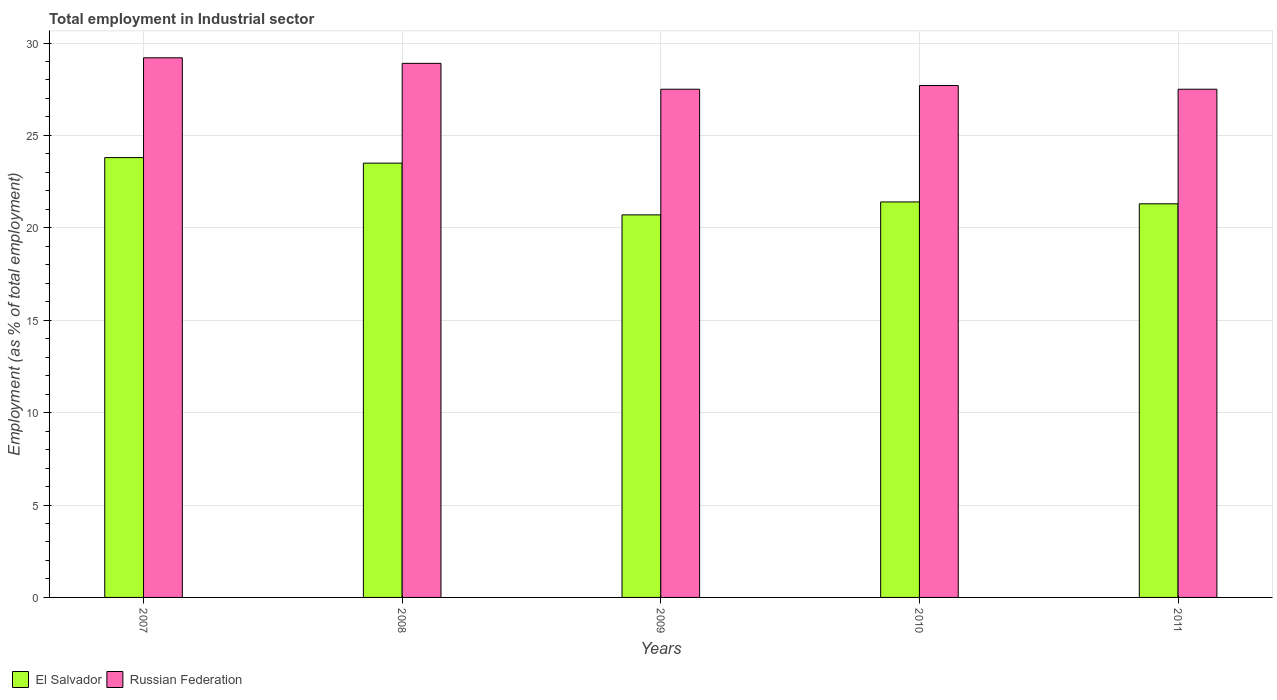How many different coloured bars are there?
Provide a short and direct response. 2. Are the number of bars per tick equal to the number of legend labels?
Offer a terse response. Yes. Are the number of bars on each tick of the X-axis equal?
Make the answer very short. Yes. How many bars are there on the 4th tick from the right?
Ensure brevity in your answer.  2. What is the label of the 2nd group of bars from the left?
Make the answer very short. 2008. In how many cases, is the number of bars for a given year not equal to the number of legend labels?
Offer a terse response. 0. What is the employment in industrial sector in Russian Federation in 2008?
Your response must be concise. 28.9. Across all years, what is the maximum employment in industrial sector in El Salvador?
Keep it short and to the point. 23.8. Across all years, what is the minimum employment in industrial sector in Russian Federation?
Make the answer very short. 27.5. In which year was the employment in industrial sector in El Salvador maximum?
Keep it short and to the point. 2007. What is the total employment in industrial sector in Russian Federation in the graph?
Keep it short and to the point. 140.8. What is the difference between the employment in industrial sector in Russian Federation in 2007 and that in 2008?
Offer a terse response. 0.3. What is the difference between the employment in industrial sector in El Salvador in 2011 and the employment in industrial sector in Russian Federation in 2010?
Give a very brief answer. -6.4. What is the average employment in industrial sector in El Salvador per year?
Provide a succinct answer. 22.14. In the year 2011, what is the difference between the employment in industrial sector in Russian Federation and employment in industrial sector in El Salvador?
Ensure brevity in your answer.  6.2. What is the ratio of the employment in industrial sector in Russian Federation in 2009 to that in 2010?
Your answer should be compact. 0.99. What is the difference between the highest and the second highest employment in industrial sector in El Salvador?
Offer a terse response. 0.3. What is the difference between the highest and the lowest employment in industrial sector in Russian Federation?
Provide a short and direct response. 1.7. In how many years, is the employment in industrial sector in El Salvador greater than the average employment in industrial sector in El Salvador taken over all years?
Offer a terse response. 2. Is the sum of the employment in industrial sector in Russian Federation in 2008 and 2010 greater than the maximum employment in industrial sector in El Salvador across all years?
Your answer should be very brief. Yes. What does the 2nd bar from the left in 2007 represents?
Your answer should be compact. Russian Federation. What does the 1st bar from the right in 2011 represents?
Provide a short and direct response. Russian Federation. How many years are there in the graph?
Provide a short and direct response. 5. What is the difference between two consecutive major ticks on the Y-axis?
Offer a terse response. 5. Does the graph contain grids?
Provide a short and direct response. Yes. How many legend labels are there?
Give a very brief answer. 2. How are the legend labels stacked?
Offer a very short reply. Horizontal. What is the title of the graph?
Make the answer very short. Total employment in Industrial sector. What is the label or title of the X-axis?
Your answer should be compact. Years. What is the label or title of the Y-axis?
Your answer should be compact. Employment (as % of total employment). What is the Employment (as % of total employment) of El Salvador in 2007?
Provide a short and direct response. 23.8. What is the Employment (as % of total employment) in Russian Federation in 2007?
Ensure brevity in your answer.  29.2. What is the Employment (as % of total employment) of Russian Federation in 2008?
Your answer should be very brief. 28.9. What is the Employment (as % of total employment) of El Salvador in 2009?
Keep it short and to the point. 20.7. What is the Employment (as % of total employment) of El Salvador in 2010?
Offer a very short reply. 21.4. What is the Employment (as % of total employment) in Russian Federation in 2010?
Your response must be concise. 27.7. What is the Employment (as % of total employment) of El Salvador in 2011?
Keep it short and to the point. 21.3. Across all years, what is the maximum Employment (as % of total employment) of El Salvador?
Provide a succinct answer. 23.8. Across all years, what is the maximum Employment (as % of total employment) of Russian Federation?
Keep it short and to the point. 29.2. Across all years, what is the minimum Employment (as % of total employment) of El Salvador?
Keep it short and to the point. 20.7. Across all years, what is the minimum Employment (as % of total employment) in Russian Federation?
Your response must be concise. 27.5. What is the total Employment (as % of total employment) in El Salvador in the graph?
Give a very brief answer. 110.7. What is the total Employment (as % of total employment) in Russian Federation in the graph?
Your answer should be very brief. 140.8. What is the difference between the Employment (as % of total employment) of El Salvador in 2007 and that in 2009?
Make the answer very short. 3.1. What is the difference between the Employment (as % of total employment) of Russian Federation in 2007 and that in 2009?
Your answer should be very brief. 1.7. What is the difference between the Employment (as % of total employment) of El Salvador in 2008 and that in 2009?
Your answer should be very brief. 2.8. What is the difference between the Employment (as % of total employment) of Russian Federation in 2008 and that in 2010?
Offer a terse response. 1.2. What is the difference between the Employment (as % of total employment) in Russian Federation in 2009 and that in 2010?
Provide a succinct answer. -0.2. What is the difference between the Employment (as % of total employment) in El Salvador in 2009 and that in 2011?
Your response must be concise. -0.6. What is the difference between the Employment (as % of total employment) in El Salvador in 2010 and that in 2011?
Give a very brief answer. 0.1. What is the difference between the Employment (as % of total employment) of El Salvador in 2007 and the Employment (as % of total employment) of Russian Federation in 2009?
Provide a succinct answer. -3.7. What is the difference between the Employment (as % of total employment) in El Salvador in 2008 and the Employment (as % of total employment) in Russian Federation in 2009?
Provide a succinct answer. -4. What is the average Employment (as % of total employment) in El Salvador per year?
Offer a very short reply. 22.14. What is the average Employment (as % of total employment) in Russian Federation per year?
Your response must be concise. 28.16. In the year 2008, what is the difference between the Employment (as % of total employment) of El Salvador and Employment (as % of total employment) of Russian Federation?
Give a very brief answer. -5.4. In the year 2009, what is the difference between the Employment (as % of total employment) of El Salvador and Employment (as % of total employment) of Russian Federation?
Make the answer very short. -6.8. In the year 2011, what is the difference between the Employment (as % of total employment) of El Salvador and Employment (as % of total employment) of Russian Federation?
Give a very brief answer. -6.2. What is the ratio of the Employment (as % of total employment) in El Salvador in 2007 to that in 2008?
Make the answer very short. 1.01. What is the ratio of the Employment (as % of total employment) of Russian Federation in 2007 to that in 2008?
Your answer should be very brief. 1.01. What is the ratio of the Employment (as % of total employment) of El Salvador in 2007 to that in 2009?
Provide a short and direct response. 1.15. What is the ratio of the Employment (as % of total employment) in Russian Federation in 2007 to that in 2009?
Your response must be concise. 1.06. What is the ratio of the Employment (as % of total employment) of El Salvador in 2007 to that in 2010?
Offer a terse response. 1.11. What is the ratio of the Employment (as % of total employment) in Russian Federation in 2007 to that in 2010?
Ensure brevity in your answer.  1.05. What is the ratio of the Employment (as % of total employment) in El Salvador in 2007 to that in 2011?
Make the answer very short. 1.12. What is the ratio of the Employment (as % of total employment) in Russian Federation in 2007 to that in 2011?
Your answer should be compact. 1.06. What is the ratio of the Employment (as % of total employment) in El Salvador in 2008 to that in 2009?
Offer a very short reply. 1.14. What is the ratio of the Employment (as % of total employment) in Russian Federation in 2008 to that in 2009?
Provide a succinct answer. 1.05. What is the ratio of the Employment (as % of total employment) in El Salvador in 2008 to that in 2010?
Your answer should be very brief. 1.1. What is the ratio of the Employment (as % of total employment) in Russian Federation in 2008 to that in 2010?
Make the answer very short. 1.04. What is the ratio of the Employment (as % of total employment) of El Salvador in 2008 to that in 2011?
Provide a short and direct response. 1.1. What is the ratio of the Employment (as % of total employment) of Russian Federation in 2008 to that in 2011?
Provide a short and direct response. 1.05. What is the ratio of the Employment (as % of total employment) in El Salvador in 2009 to that in 2010?
Provide a succinct answer. 0.97. What is the ratio of the Employment (as % of total employment) in El Salvador in 2009 to that in 2011?
Your response must be concise. 0.97. What is the ratio of the Employment (as % of total employment) of Russian Federation in 2009 to that in 2011?
Make the answer very short. 1. What is the ratio of the Employment (as % of total employment) in El Salvador in 2010 to that in 2011?
Keep it short and to the point. 1. What is the ratio of the Employment (as % of total employment) of Russian Federation in 2010 to that in 2011?
Make the answer very short. 1.01. What is the difference between the highest and the second highest Employment (as % of total employment) in El Salvador?
Ensure brevity in your answer.  0.3. What is the difference between the highest and the lowest Employment (as % of total employment) of Russian Federation?
Make the answer very short. 1.7. 